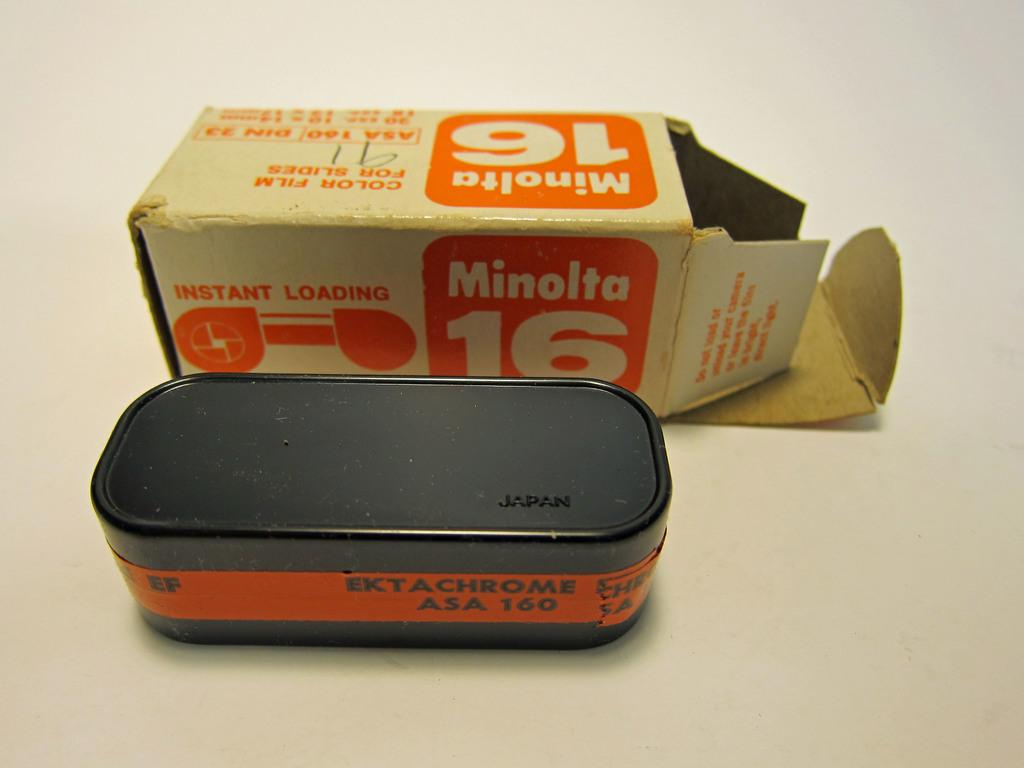<image>
Share a concise interpretation of the image provided. An old box of Minolta film with orange writing. 